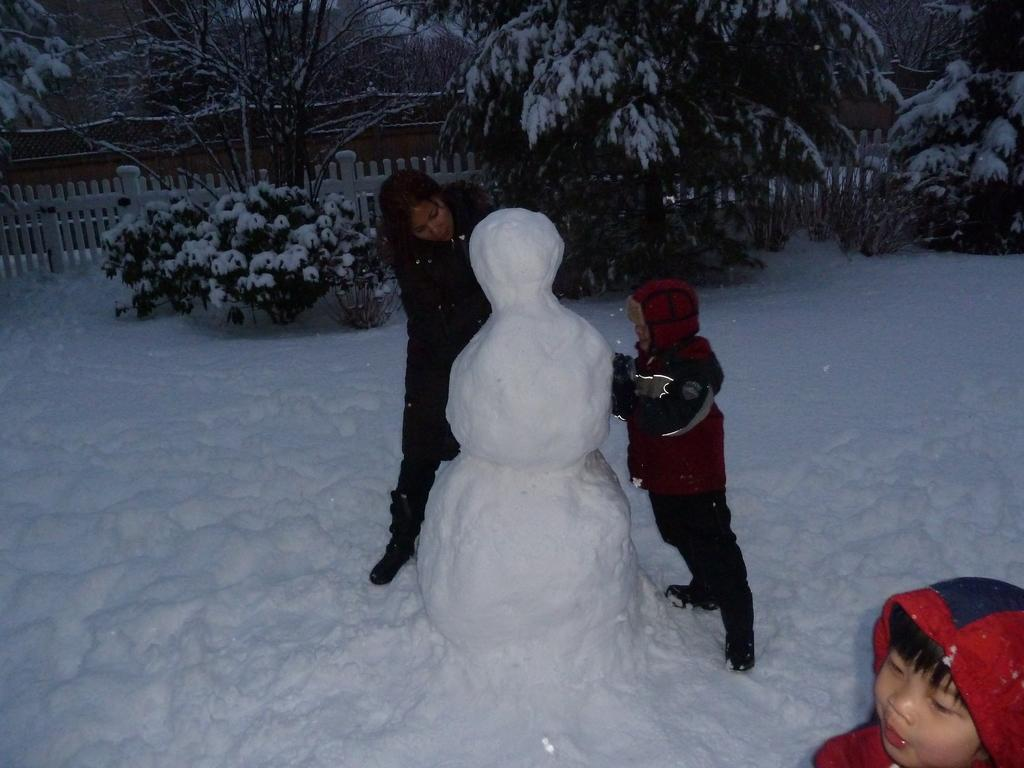What is the main subject in the image? There is a snow doll in the image. How many people are present in the image? There are three people standing in the image. What type of fencing can be seen in the image? There is white color fencing visible in the image. What can be seen in the background of the image? There are trees in the background of the image. What type of structure is visible in the image? There is a house in the image. What is the weather condition in the image? There is snow visible in the image, indicating a snowy environment. What type of front is visible in the image? There is no specific "front" mentioned in the image; it is a scene with a snow doll, people, fencing, trees, a house, and snow. --- 